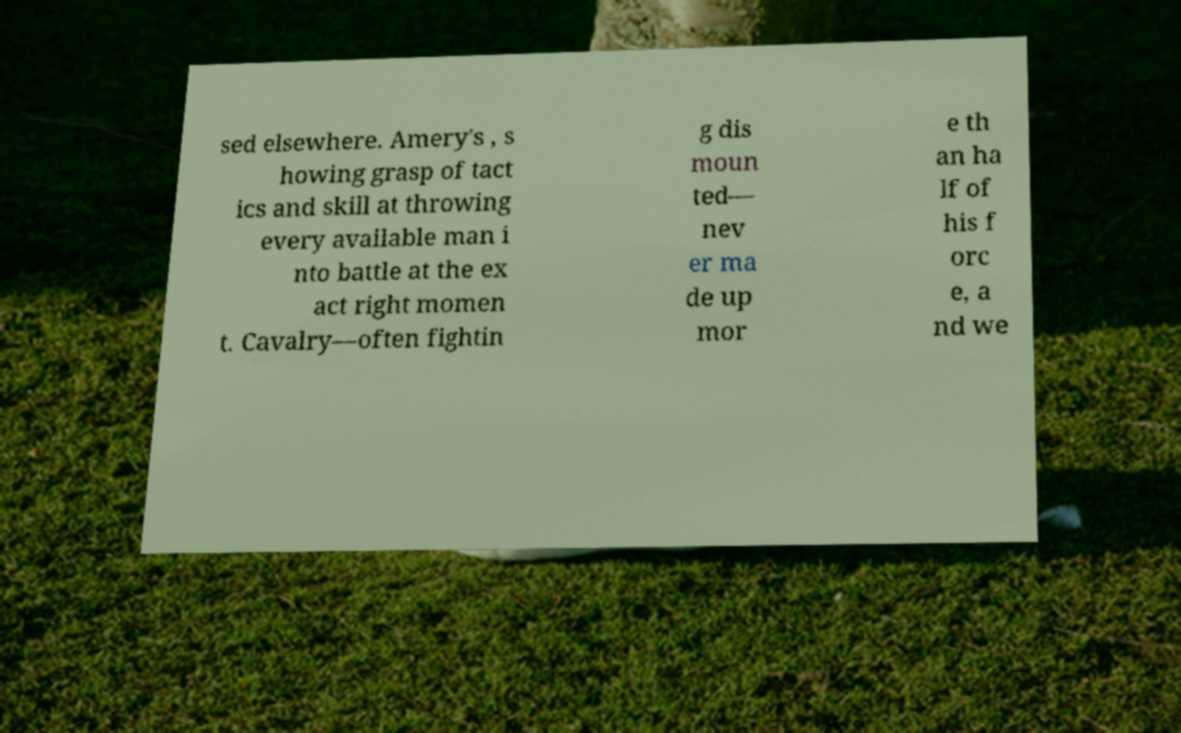Please identify and transcribe the text found in this image. sed elsewhere. Amery's , s howing grasp of tact ics and skill at throwing every available man i nto battle at the ex act right momen t. Cavalry—often fightin g dis moun ted— nev er ma de up mor e th an ha lf of his f orc e, a nd we 